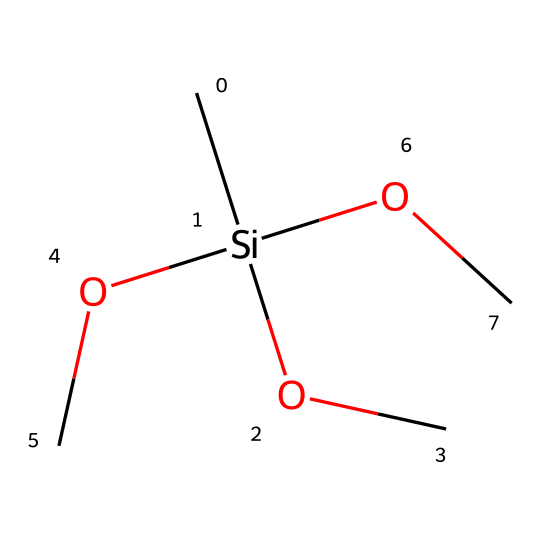What is the core element of this silane? The core element of the silane is silicon, which is evident from the 'Si' in the SMILES structure.
Answer: silicon How many methoxy groups are present? The SMILES indicates three methoxy groups (OC), as each 'OC' represents one methoxy group connected to the silicon atom.
Answer: three What is the general category of this chemical? The chemical belongs to the category of silanes, as it features a silicon atom bonded to organic radicals (methoxy groups in this case).
Answer: silanes How many total atoms are in the structure? The total atom count includes 1 silicon (Si), 1 carbon (C) for each of the three methoxy groups, and 3 oxygens (O) from the methoxy groups, resulting in a total of 10 atoms in the entire structure.
Answer: ten What role do silane coupling agents play in dental applications? Silane coupling agents serve as bonding agents that enhance adhesion between inorganic materials and organic polymers in dental adhesives.
Answer: bonding agents Which functional groups are present in this silane? The functional groups present are methoxy groups, represented by 'OC' in the structure, indicating the presence of an ether-like character.
Answer: methoxy groups What type of reaction can this silane undergo in dental applications? This silane can undergo hydrolysis in the presence of moisture, allowing it to react with substrates for improved adhesion in dental materials.
Answer: hydrolysis 